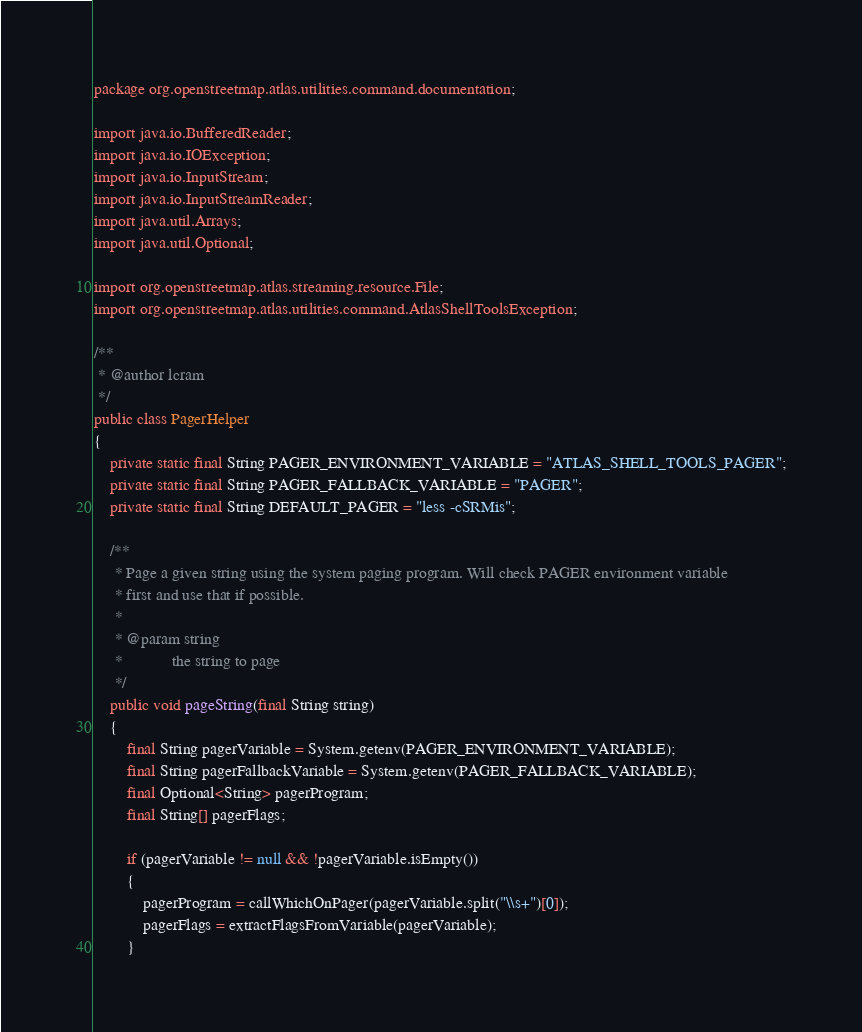<code> <loc_0><loc_0><loc_500><loc_500><_Java_>package org.openstreetmap.atlas.utilities.command.documentation;

import java.io.BufferedReader;
import java.io.IOException;
import java.io.InputStream;
import java.io.InputStreamReader;
import java.util.Arrays;
import java.util.Optional;

import org.openstreetmap.atlas.streaming.resource.File;
import org.openstreetmap.atlas.utilities.command.AtlasShellToolsException;

/**
 * @author lcram
 */
public class PagerHelper
{
    private static final String PAGER_ENVIRONMENT_VARIABLE = "ATLAS_SHELL_TOOLS_PAGER";
    private static final String PAGER_FALLBACK_VARIABLE = "PAGER";
    private static final String DEFAULT_PAGER = "less -cSRMis";

    /**
     * Page a given string using the system paging program. Will check PAGER environment variable
     * first and use that if possible.
     *
     * @param string
     *            the string to page
     */
    public void pageString(final String string)
    {
        final String pagerVariable = System.getenv(PAGER_ENVIRONMENT_VARIABLE);
        final String pagerFallbackVariable = System.getenv(PAGER_FALLBACK_VARIABLE);
        final Optional<String> pagerProgram;
        final String[] pagerFlags;

        if (pagerVariable != null && !pagerVariable.isEmpty())
        {
            pagerProgram = callWhichOnPager(pagerVariable.split("\\s+")[0]);
            pagerFlags = extractFlagsFromVariable(pagerVariable);
        }</code> 